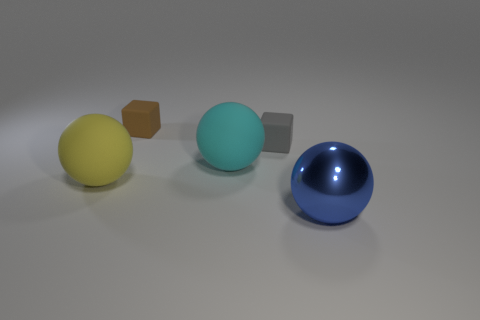Is there any other thing that has the same material as the brown thing?
Make the answer very short. Yes. There is a rubber object in front of the large matte thing right of the ball that is on the left side of the tiny brown object; what size is it?
Provide a succinct answer. Large. There is a small brown matte block; how many rubber balls are to the left of it?
Keep it short and to the point. 1. Are there more tiny rubber cylinders than large blue metallic things?
Ensure brevity in your answer.  No. There is a object that is both behind the big yellow matte object and to the left of the large cyan ball; what is its size?
Give a very brief answer. Small. What is the big object that is right of the rubber cube that is on the right side of the ball behind the yellow rubber object made of?
Offer a terse response. Metal. There is a large thing that is in front of the large yellow matte ball; is it the same color as the large rubber ball on the left side of the small brown matte thing?
Provide a succinct answer. No. There is a small thing on the right side of the big rubber sphere on the right side of the tiny cube on the left side of the gray matte thing; what shape is it?
Offer a terse response. Cube. There is a matte object that is behind the big yellow rubber object and to the left of the large cyan rubber thing; what is its shape?
Your answer should be very brief. Cube. There is a cube on the right side of the rubber sphere that is on the right side of the tiny brown block; how many tiny gray matte blocks are on the right side of it?
Provide a short and direct response. 0. 